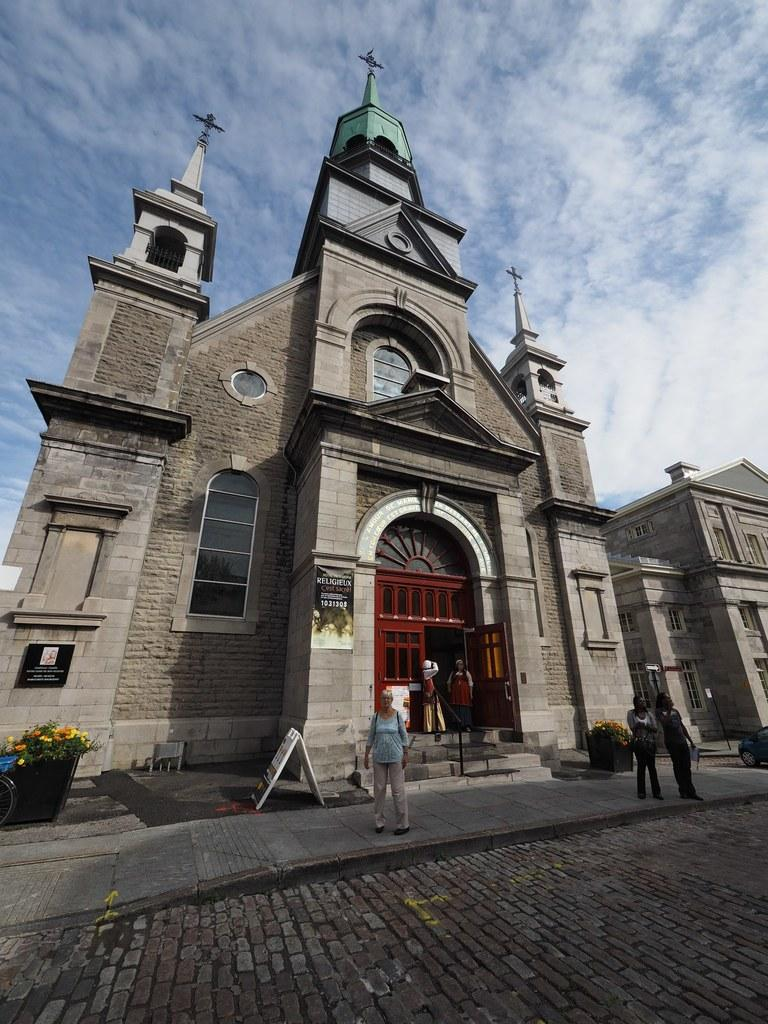What is located in the center of the image? There are buildings in the center of the image. What can be seen at the bottom of the image? There are plants, flowers, a board, persons, and a road at the bottom of the image. What is visible in the background of the image? The sky is visible in the background of the image, and there are clouds present. What type of cream is being used in the verse written on the board at the bottom of the image? There is no cream or verse present on the board in the image; it only shows plants, flowers, persons, and a road. 